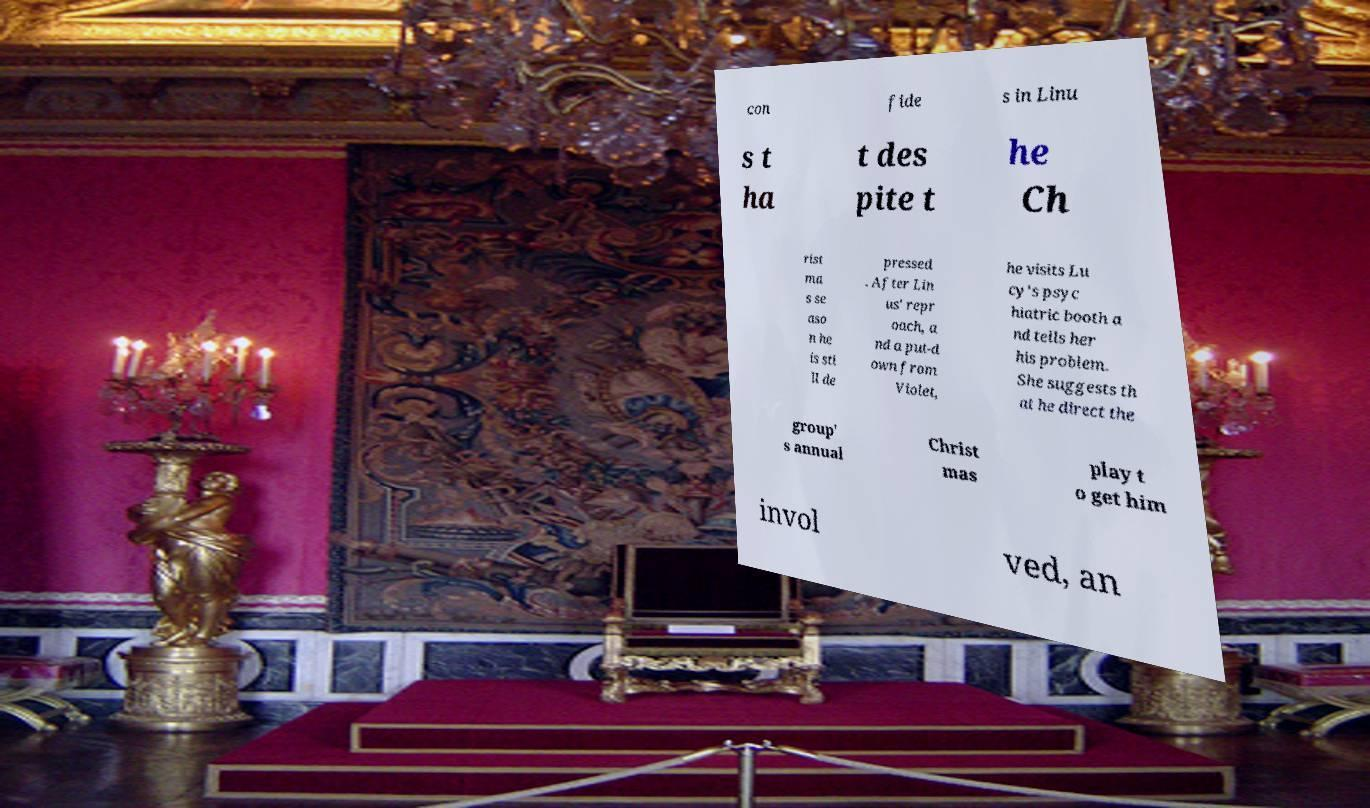Please read and relay the text visible in this image. What does it say? con fide s in Linu s t ha t des pite t he Ch rist ma s se aso n he is sti ll de pressed . After Lin us' repr oach, a nd a put-d own from Violet, he visits Lu cy's psyc hiatric booth a nd tells her his problem. She suggests th at he direct the group' s annual Christ mas play t o get him invol ved, an 